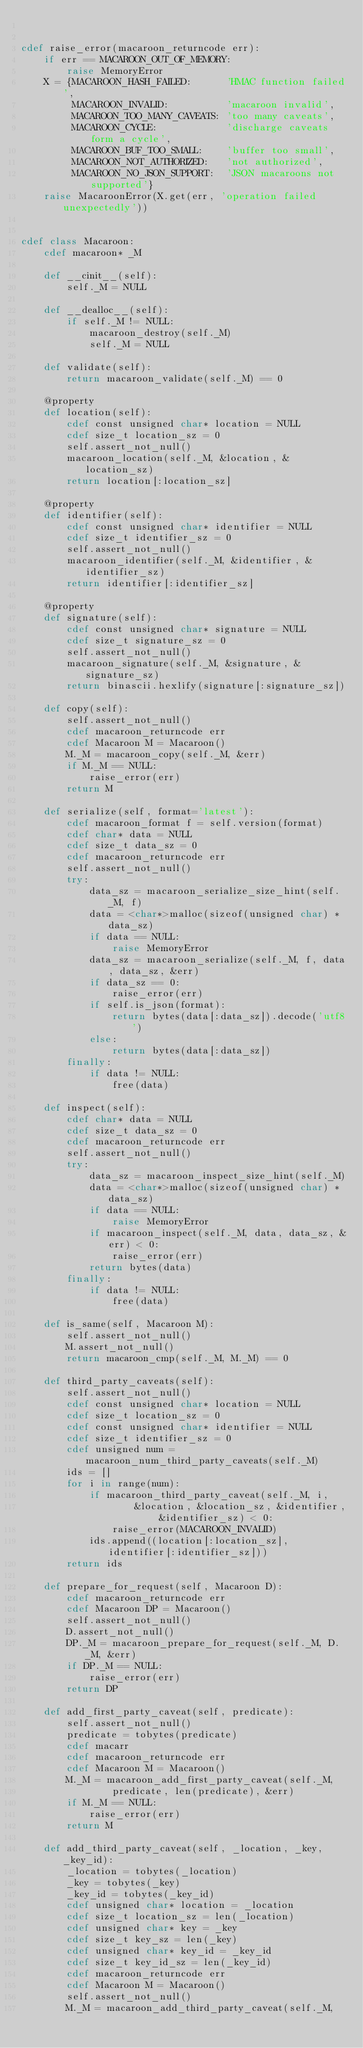<code> <loc_0><loc_0><loc_500><loc_500><_Cython_>

cdef raise_error(macaroon_returncode err):
    if err == MACAROON_OUT_OF_MEMORY:
        raise MemoryError
    X = {MACAROON_HASH_FAILED:      'HMAC function failed',
         MACAROON_INVALID:          'macaroon invalid',
         MACAROON_TOO_MANY_CAVEATS: 'too many caveats',
         MACAROON_CYCLE:            'discharge caveats form a cycle',
         MACAROON_BUF_TOO_SMALL:    'buffer too small',
         MACAROON_NOT_AUTHORIZED:   'not authorized',
         MACAROON_NO_JSON_SUPPORT:  'JSON macaroons not supported'}
    raise MacaroonError(X.get(err, 'operation failed unexpectedly'))


cdef class Macaroon:
    cdef macaroon* _M

    def __cinit__(self):
        self._M = NULL

    def __dealloc__(self):
        if self._M != NULL:
            macaroon_destroy(self._M)
            self._M = NULL

    def validate(self):
        return macaroon_validate(self._M) == 0

    @property
    def location(self):
        cdef const unsigned char* location = NULL
        cdef size_t location_sz = 0
        self.assert_not_null()
        macaroon_location(self._M, &location, &location_sz)
        return location[:location_sz]

    @property
    def identifier(self):
        cdef const unsigned char* identifier = NULL
        cdef size_t identifier_sz = 0
        self.assert_not_null()
        macaroon_identifier(self._M, &identifier, &identifier_sz)
        return identifier[:identifier_sz]

    @property
    def signature(self):
        cdef const unsigned char* signature = NULL
        cdef size_t signature_sz = 0
        self.assert_not_null()
        macaroon_signature(self._M, &signature, &signature_sz)
        return binascii.hexlify(signature[:signature_sz])

    def copy(self):
        self.assert_not_null()
        cdef macaroon_returncode err
        cdef Macaroon M = Macaroon()
        M._M = macaroon_copy(self._M, &err)
        if M._M == NULL:
            raise_error(err)
        return M

    def serialize(self, format='latest'):
        cdef macaroon_format f = self.version(format)
        cdef char* data = NULL
        cdef size_t data_sz = 0
        cdef macaroon_returncode err
        self.assert_not_null()
        try:
            data_sz = macaroon_serialize_size_hint(self._M, f)
            data = <char*>malloc(sizeof(unsigned char) * data_sz)
            if data == NULL:
                raise MemoryError
            data_sz = macaroon_serialize(self._M, f, data, data_sz, &err)
            if data_sz == 0:
                raise_error(err)
            if self.is_json(format):
                return bytes(data[:data_sz]).decode('utf8')
            else:
                return bytes(data[:data_sz])
        finally:
            if data != NULL:
                free(data)

    def inspect(self):
        cdef char* data = NULL
        cdef size_t data_sz = 0
        cdef macaroon_returncode err
        self.assert_not_null()
        try:
            data_sz = macaroon_inspect_size_hint(self._M)
            data = <char*>malloc(sizeof(unsigned char) * data_sz)
            if data == NULL:
                raise MemoryError
            if macaroon_inspect(self._M, data, data_sz, &err) < 0:
                raise_error(err)
            return bytes(data)
        finally:
            if data != NULL:
                free(data)

    def is_same(self, Macaroon M):
        self.assert_not_null()
        M.assert_not_null()
        return macaroon_cmp(self._M, M._M) == 0

    def third_party_caveats(self):
        self.assert_not_null()
        cdef const unsigned char* location = NULL
        cdef size_t location_sz = 0
        cdef const unsigned char* identifier = NULL
        cdef size_t identifier_sz = 0
        cdef unsigned num = macaroon_num_third_party_caveats(self._M)
        ids = []
        for i in range(num):
            if macaroon_third_party_caveat(self._M, i,
                    &location, &location_sz, &identifier, &identifier_sz) < 0:
                raise_error(MACAROON_INVALID)
            ids.append((location[:location_sz], identifier[:identifier_sz]))
        return ids

    def prepare_for_request(self, Macaroon D):
        cdef macaroon_returncode err
        cdef Macaroon DP = Macaroon()
        self.assert_not_null()
        D.assert_not_null()
        DP._M = macaroon_prepare_for_request(self._M, D._M, &err)
        if DP._M == NULL:
            raise_error(err)
        return DP

    def add_first_party_caveat(self, predicate):
        self.assert_not_null()
        predicate = tobytes(predicate)
        cdef macarr
        cdef macaroon_returncode err
        cdef Macaroon M = Macaroon()
        M._M = macaroon_add_first_party_caveat(self._M,
                predicate, len(predicate), &err)
        if M._M == NULL:
            raise_error(err)
        return M

    def add_third_party_caveat(self, _location, _key, _key_id):
        _location = tobytes(_location)
        _key = tobytes(_key)
        _key_id = tobytes(_key_id)
        cdef unsigned char* location = _location
        cdef size_t location_sz = len(_location)
        cdef unsigned char* key = _key
        cdef size_t key_sz = len(_key)
        cdef unsigned char* key_id = _key_id
        cdef size_t key_id_sz = len(_key_id)
        cdef macaroon_returncode err
        cdef Macaroon M = Macaroon()
        self.assert_not_null()
        M._M = macaroon_add_third_party_caveat(self._M,</code> 